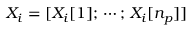Convert formula to latex. <formula><loc_0><loc_0><loc_500><loc_500>X _ { i } = [ X _ { i } [ 1 ] ; \, \cdots ; \, X _ { i } [ n _ { p } ] ]</formula> 